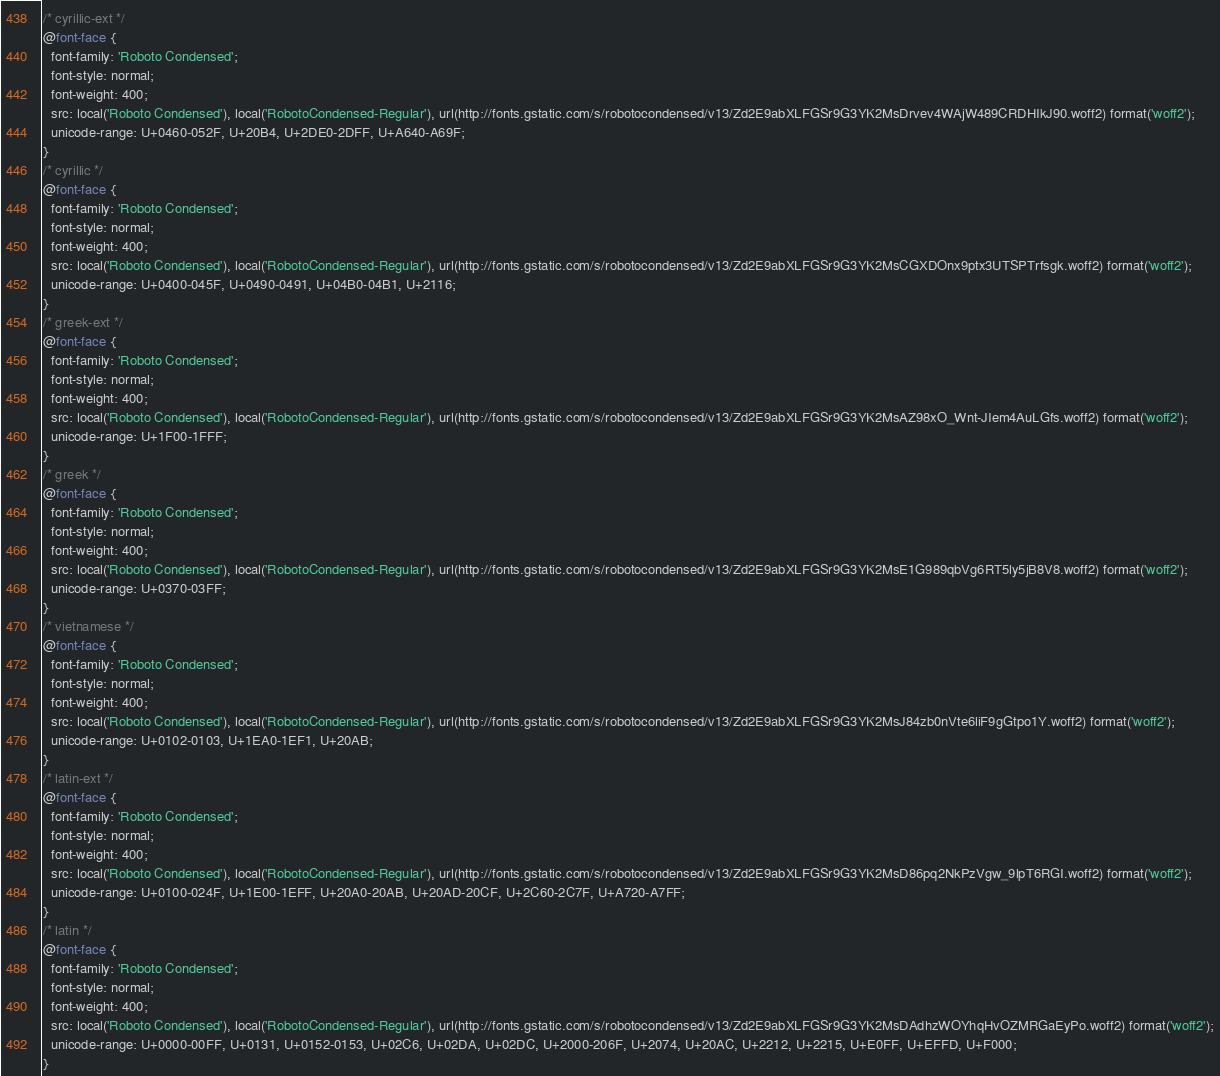<code> <loc_0><loc_0><loc_500><loc_500><_CSS_>/* cyrillic-ext */
@font-face {
  font-family: 'Roboto Condensed';
  font-style: normal;
  font-weight: 400;
  src: local('Roboto Condensed'), local('RobotoCondensed-Regular'), url(http://fonts.gstatic.com/s/robotocondensed/v13/Zd2E9abXLFGSr9G3YK2MsDrvev4WAjW489CRDHIkJ90.woff2) format('woff2');
  unicode-range: U+0460-052F, U+20B4, U+2DE0-2DFF, U+A640-A69F;
}
/* cyrillic */
@font-face {
  font-family: 'Roboto Condensed';
  font-style: normal;
  font-weight: 400;
  src: local('Roboto Condensed'), local('RobotoCondensed-Regular'), url(http://fonts.gstatic.com/s/robotocondensed/v13/Zd2E9abXLFGSr9G3YK2MsCGXDOnx9ptx3UTSPTrfsgk.woff2) format('woff2');
  unicode-range: U+0400-045F, U+0490-0491, U+04B0-04B1, U+2116;
}
/* greek-ext */
@font-face {
  font-family: 'Roboto Condensed';
  font-style: normal;
  font-weight: 400;
  src: local('Roboto Condensed'), local('RobotoCondensed-Regular'), url(http://fonts.gstatic.com/s/robotocondensed/v13/Zd2E9abXLFGSr9G3YK2MsAZ98xO_Wnt-JIem4AuLGfs.woff2) format('woff2');
  unicode-range: U+1F00-1FFF;
}
/* greek */
@font-face {
  font-family: 'Roboto Condensed';
  font-style: normal;
  font-weight: 400;
  src: local('Roboto Condensed'), local('RobotoCondensed-Regular'), url(http://fonts.gstatic.com/s/robotocondensed/v13/Zd2E9abXLFGSr9G3YK2MsE1G989qbVg6RT5ly5jB8V8.woff2) format('woff2');
  unicode-range: U+0370-03FF;
}
/* vietnamese */
@font-face {
  font-family: 'Roboto Condensed';
  font-style: normal;
  font-weight: 400;
  src: local('Roboto Condensed'), local('RobotoCondensed-Regular'), url(http://fonts.gstatic.com/s/robotocondensed/v13/Zd2E9abXLFGSr9G3YK2MsJ84zb0nVte6liF9gGtpo1Y.woff2) format('woff2');
  unicode-range: U+0102-0103, U+1EA0-1EF1, U+20AB;
}
/* latin-ext */
@font-face {
  font-family: 'Roboto Condensed';
  font-style: normal;
  font-weight: 400;
  src: local('Roboto Condensed'), local('RobotoCondensed-Regular'), url(http://fonts.gstatic.com/s/robotocondensed/v13/Zd2E9abXLFGSr9G3YK2MsD86pq2NkPzVgw_9lpT6RGI.woff2) format('woff2');
  unicode-range: U+0100-024F, U+1E00-1EFF, U+20A0-20AB, U+20AD-20CF, U+2C60-2C7F, U+A720-A7FF;
}
/* latin */
@font-face {
  font-family: 'Roboto Condensed';
  font-style: normal;
  font-weight: 400;
  src: local('Roboto Condensed'), local('RobotoCondensed-Regular'), url(http://fonts.gstatic.com/s/robotocondensed/v13/Zd2E9abXLFGSr9G3YK2MsDAdhzWOYhqHvOZMRGaEyPo.woff2) format('woff2');
  unicode-range: U+0000-00FF, U+0131, U+0152-0153, U+02C6, U+02DA, U+02DC, U+2000-206F, U+2074, U+20AC, U+2212, U+2215, U+E0FF, U+EFFD, U+F000;
}</code> 